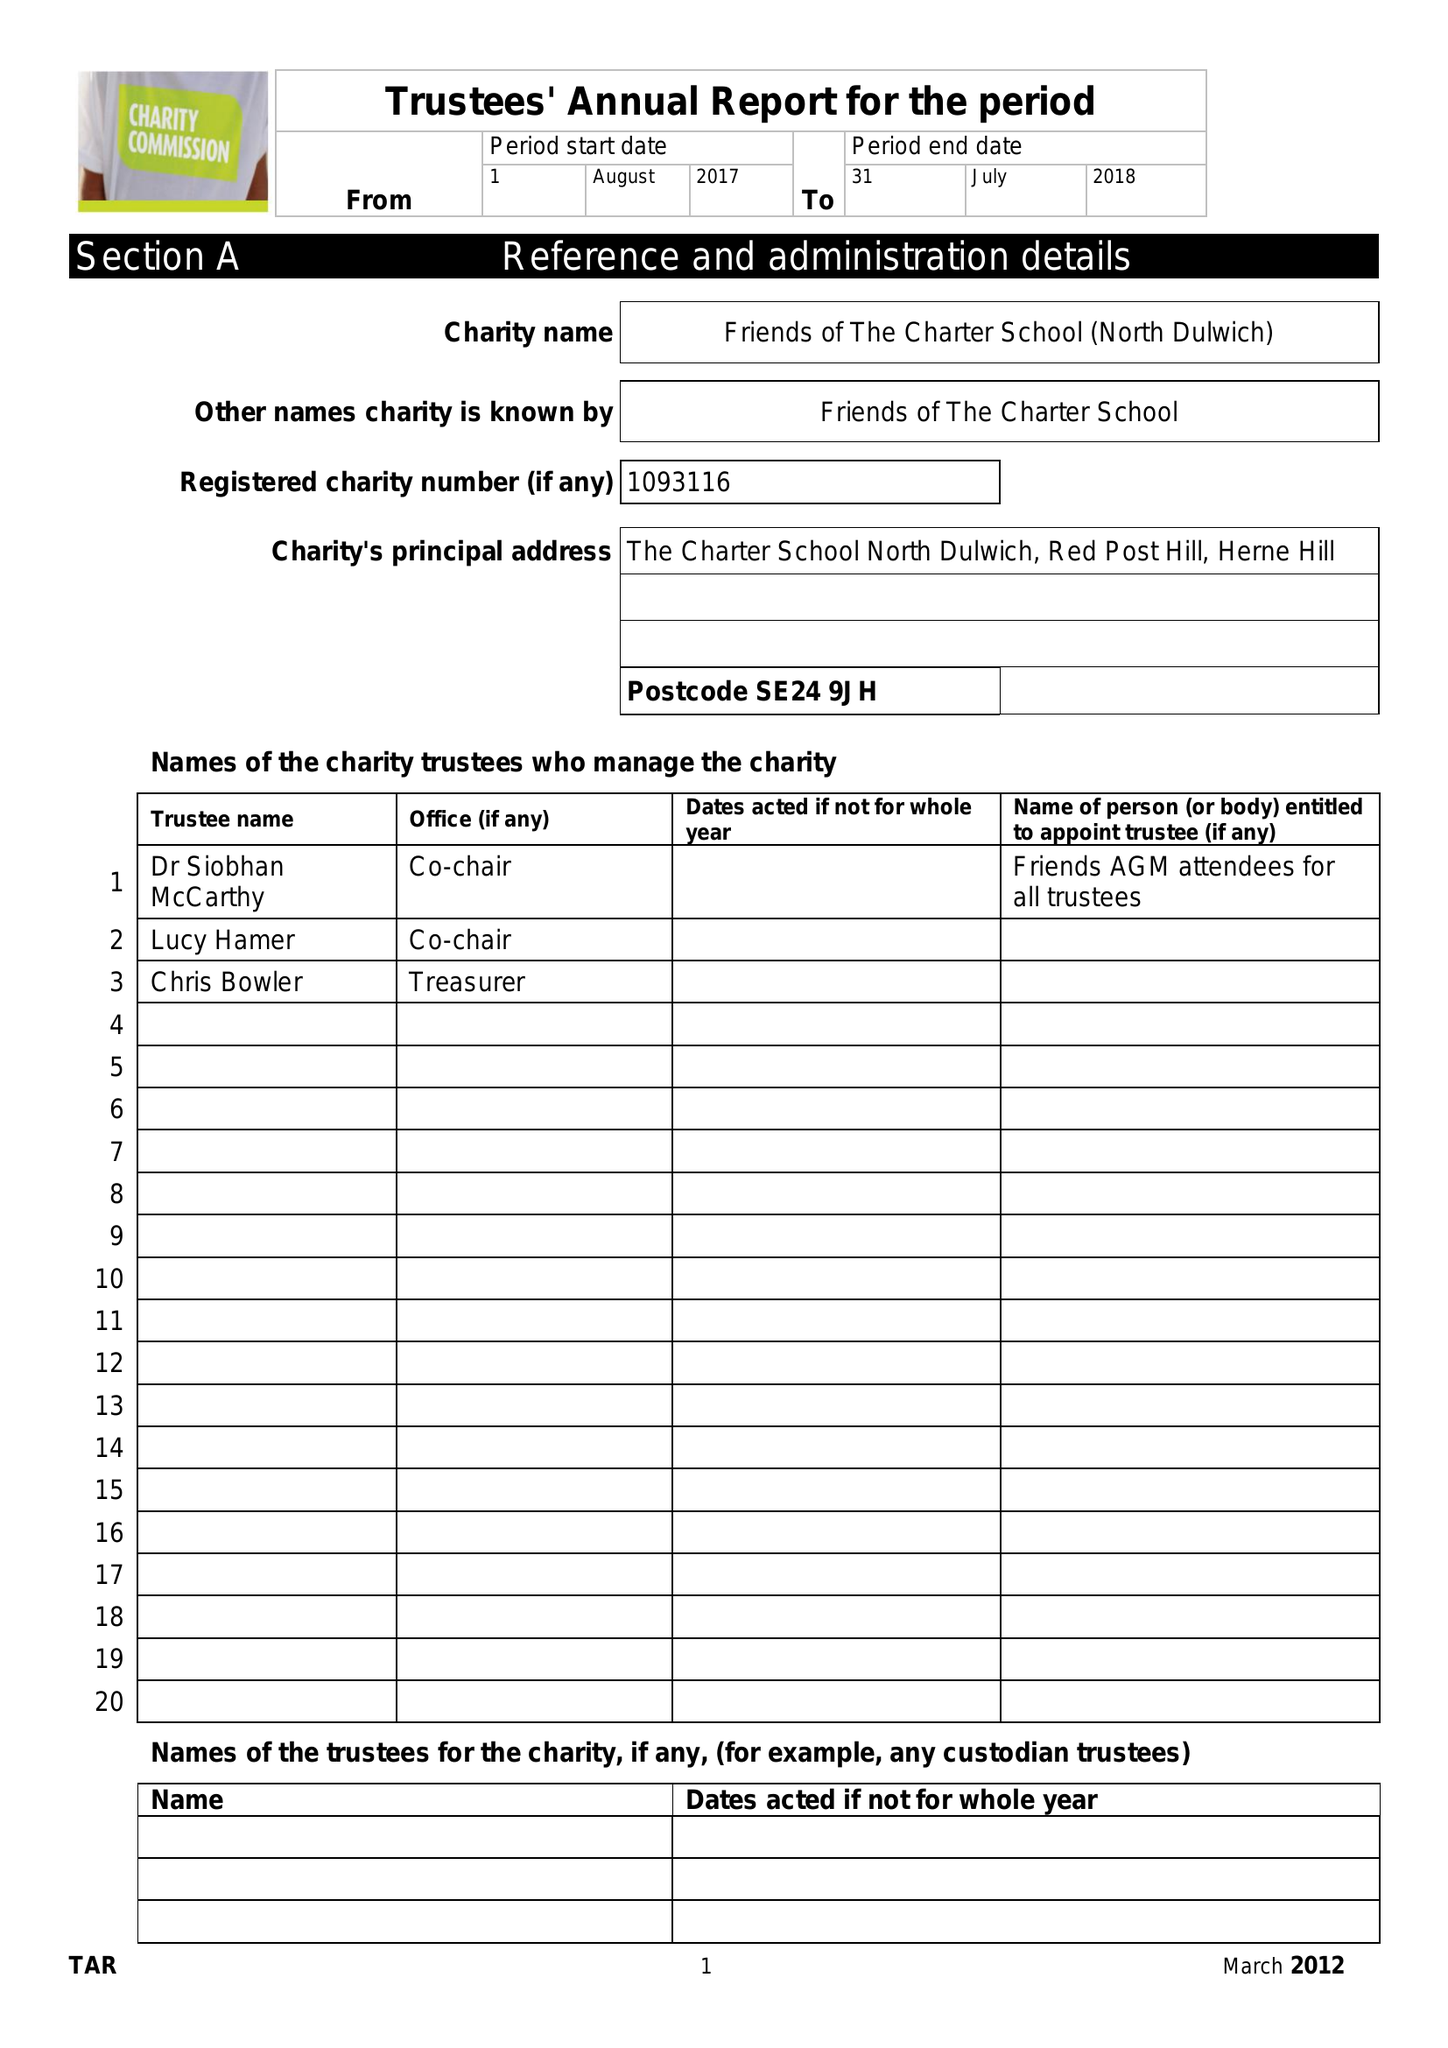What is the value for the address__street_line?
Answer the question using a single word or phrase. RED POST HILL 